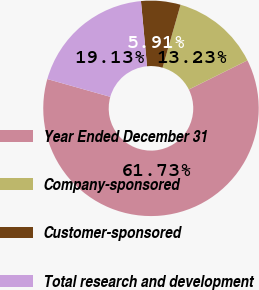Convert chart. <chart><loc_0><loc_0><loc_500><loc_500><pie_chart><fcel>Year Ended December 31<fcel>Company-sponsored<fcel>Customer-sponsored<fcel>Total research and development<nl><fcel>61.73%<fcel>13.23%<fcel>5.91%<fcel>19.13%<nl></chart> 